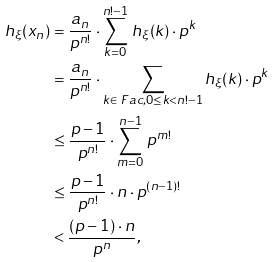Convert formula to latex. <formula><loc_0><loc_0><loc_500><loc_500>h _ { \xi } ( x _ { n } ) & = \frac { a _ { n } } { p ^ { n ! } } \cdot \sum _ { k = 0 } ^ { n ! - 1 } \, h _ { \xi } ( k ) \cdot p ^ { k } \\ & = \frac { a _ { n } } { p ^ { n ! } } \cdot \sum _ { k \in \ F a c , 0 \leq k < n ! - 1 } h _ { \xi } ( k ) \cdot p ^ { k } \\ & \leq \frac { p - 1 } { p ^ { n ! } } \cdot \sum _ { m = 0 } ^ { n - 1 } \, p ^ { m ! } \\ & \leq \frac { p - 1 } { p ^ { n ! } } \cdot n \cdot p ^ { ( n - 1 ) ! } \\ & < \frac { ( p - 1 ) \cdot n } { p ^ { n } } ,</formula> 